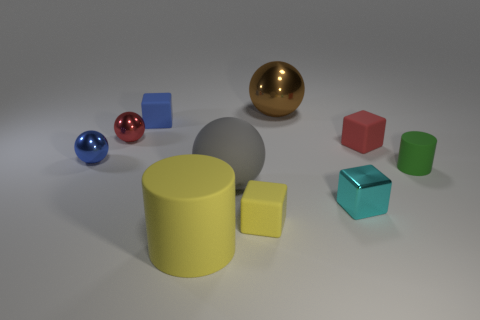Subtract 1 cubes. How many cubes are left? 3 Subtract all cubes. How many objects are left? 6 Subtract 1 cyan cubes. How many objects are left? 9 Subtract all green rubber cylinders. Subtract all small red rubber cubes. How many objects are left? 8 Add 6 cyan shiny things. How many cyan shiny things are left? 7 Add 6 cyan spheres. How many cyan spheres exist? 6 